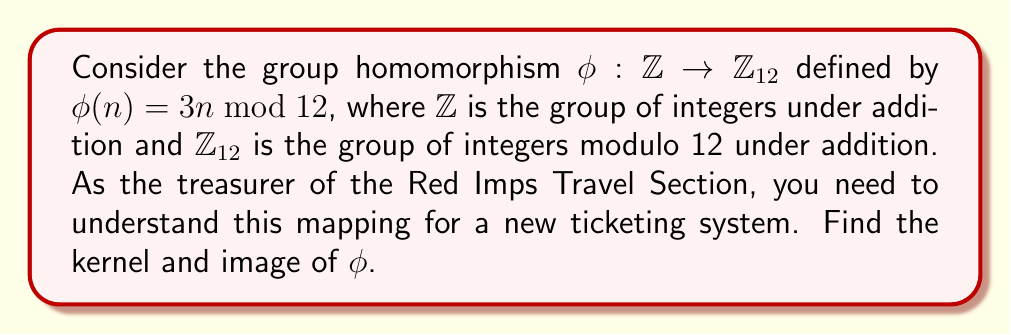Could you help me with this problem? To find the kernel and image of the group homomorphism $\phi$, we'll follow these steps:

1) Kernel:
   The kernel of $\phi$ is the set of all elements in $\mathbb{Z}$ that map to the identity element in $\mathbb{Z}_{12}$ (which is 0).

   $\ker(\phi) = \{n \in \mathbb{Z} : \phi(n) = 0\}$

   We need to solve the equation:
   $3n \equiv 0 \pmod{12}$

   This is equivalent to:
   $12k = 3n$ for some integer $k$
   $4k = n$

   Therefore, $\ker(\phi) = \{4k : k \in \mathbb{Z}\} = 4\mathbb{Z}$

2) Image:
   The image of $\phi$ is the set of all elements in $\mathbb{Z}_{12}$ that are outputs of $\phi$.

   $\text{Im}(\phi) = \{\phi(n) : n \in \mathbb{Z}\}$

   Let's calculate $\phi(n)$ for $n = 0, 1, 2, 3$:
   $\phi(0) = 0$
   $\phi(1) = 3$
   $\phi(2) = 6$
   $\phi(3) = 9$
   $\phi(4) = 0$

   We see that the pattern repeats after $\phi(3)$. Therefore,

   $\text{Im}(\phi) = \{0, 3, 6, 9\}$

   This can also be written as $\{3k \bmod 12 : k \in \mathbb{Z}\}$ or $3\mathbb{Z}_{12}$.
Answer: Kernel: $\ker(\phi) = 4\mathbb{Z} = \{4k : k \in \mathbb{Z}\}$
Image: $\text{Im}(\phi) = \{0, 3, 6, 9\} = 3\mathbb{Z}_{12}$ 